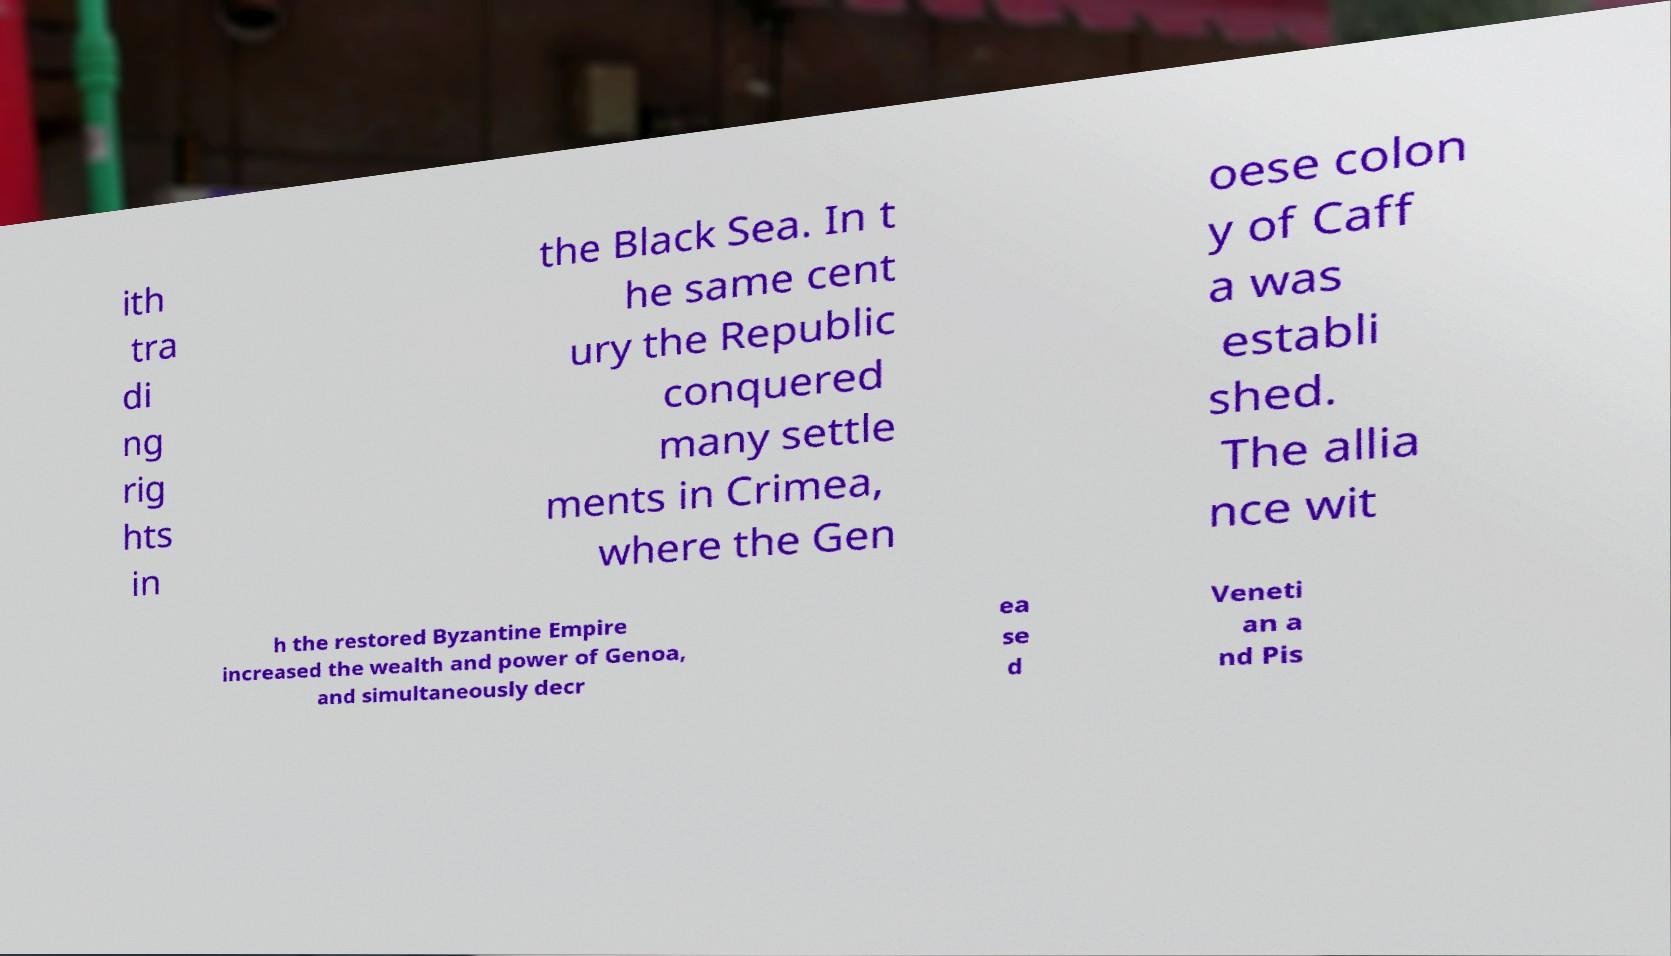There's text embedded in this image that I need extracted. Can you transcribe it verbatim? ith tra di ng rig hts in the Black Sea. In t he same cent ury the Republic conquered many settle ments in Crimea, where the Gen oese colon y of Caff a was establi shed. The allia nce wit h the restored Byzantine Empire increased the wealth and power of Genoa, and simultaneously decr ea se d Veneti an a nd Pis 